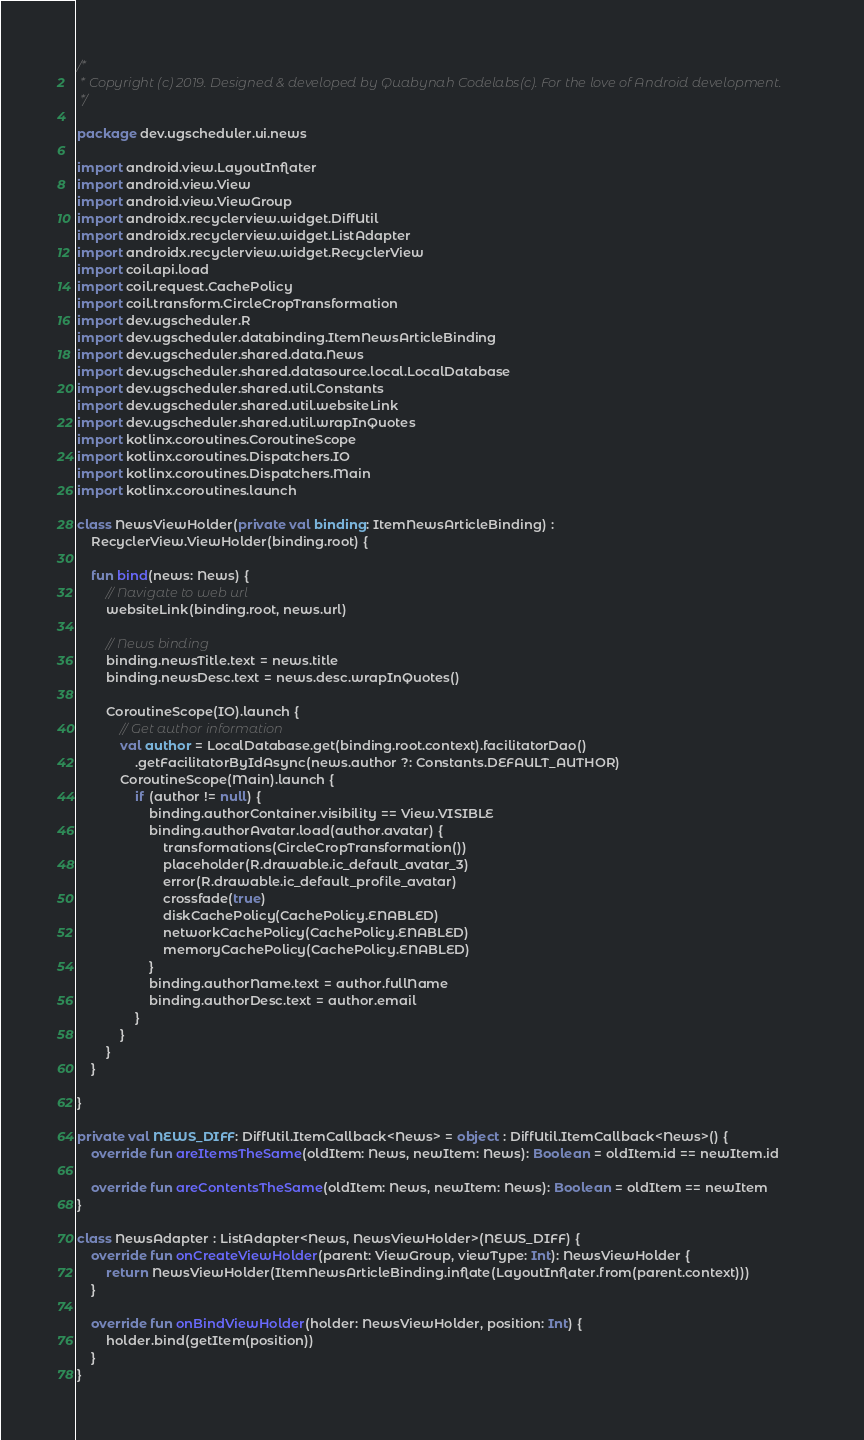<code> <loc_0><loc_0><loc_500><loc_500><_Kotlin_>/*
 * Copyright (c) 2019. Designed & developed by Quabynah Codelabs(c). For the love of Android development.
 */

package dev.ugscheduler.ui.news

import android.view.LayoutInflater
import android.view.View
import android.view.ViewGroup
import androidx.recyclerview.widget.DiffUtil
import androidx.recyclerview.widget.ListAdapter
import androidx.recyclerview.widget.RecyclerView
import coil.api.load
import coil.request.CachePolicy
import coil.transform.CircleCropTransformation
import dev.ugscheduler.R
import dev.ugscheduler.databinding.ItemNewsArticleBinding
import dev.ugscheduler.shared.data.News
import dev.ugscheduler.shared.datasource.local.LocalDatabase
import dev.ugscheduler.shared.util.Constants
import dev.ugscheduler.shared.util.websiteLink
import dev.ugscheduler.shared.util.wrapInQuotes
import kotlinx.coroutines.CoroutineScope
import kotlinx.coroutines.Dispatchers.IO
import kotlinx.coroutines.Dispatchers.Main
import kotlinx.coroutines.launch

class NewsViewHolder(private val binding: ItemNewsArticleBinding) :
    RecyclerView.ViewHolder(binding.root) {

    fun bind(news: News) {
        // Navigate to web url
        websiteLink(binding.root, news.url)

        // News binding
        binding.newsTitle.text = news.title
        binding.newsDesc.text = news.desc.wrapInQuotes()

        CoroutineScope(IO).launch {
            // Get author information
            val author = LocalDatabase.get(binding.root.context).facilitatorDao()
                .getFacilitatorByIdAsync(news.author ?: Constants.DEFAULT_AUTHOR)
            CoroutineScope(Main).launch {
                if (author != null) {
                    binding.authorContainer.visibility == View.VISIBLE
                    binding.authorAvatar.load(author.avatar) {
                        transformations(CircleCropTransformation())
                        placeholder(R.drawable.ic_default_avatar_3)
                        error(R.drawable.ic_default_profile_avatar)
                        crossfade(true)
                        diskCachePolicy(CachePolicy.ENABLED)
                        networkCachePolicy(CachePolicy.ENABLED)
                        memoryCachePolicy(CachePolicy.ENABLED)
                    }
                    binding.authorName.text = author.fullName
                    binding.authorDesc.text = author.email
                }
            }
        }
    }

}

private val NEWS_DIFF: DiffUtil.ItemCallback<News> = object : DiffUtil.ItemCallback<News>() {
    override fun areItemsTheSame(oldItem: News, newItem: News): Boolean = oldItem.id == newItem.id

    override fun areContentsTheSame(oldItem: News, newItem: News): Boolean = oldItem == newItem
}

class NewsAdapter : ListAdapter<News, NewsViewHolder>(NEWS_DIFF) {
    override fun onCreateViewHolder(parent: ViewGroup, viewType: Int): NewsViewHolder {
        return NewsViewHolder(ItemNewsArticleBinding.inflate(LayoutInflater.from(parent.context)))
    }

    override fun onBindViewHolder(holder: NewsViewHolder, position: Int) {
        holder.bind(getItem(position))
    }
}</code> 